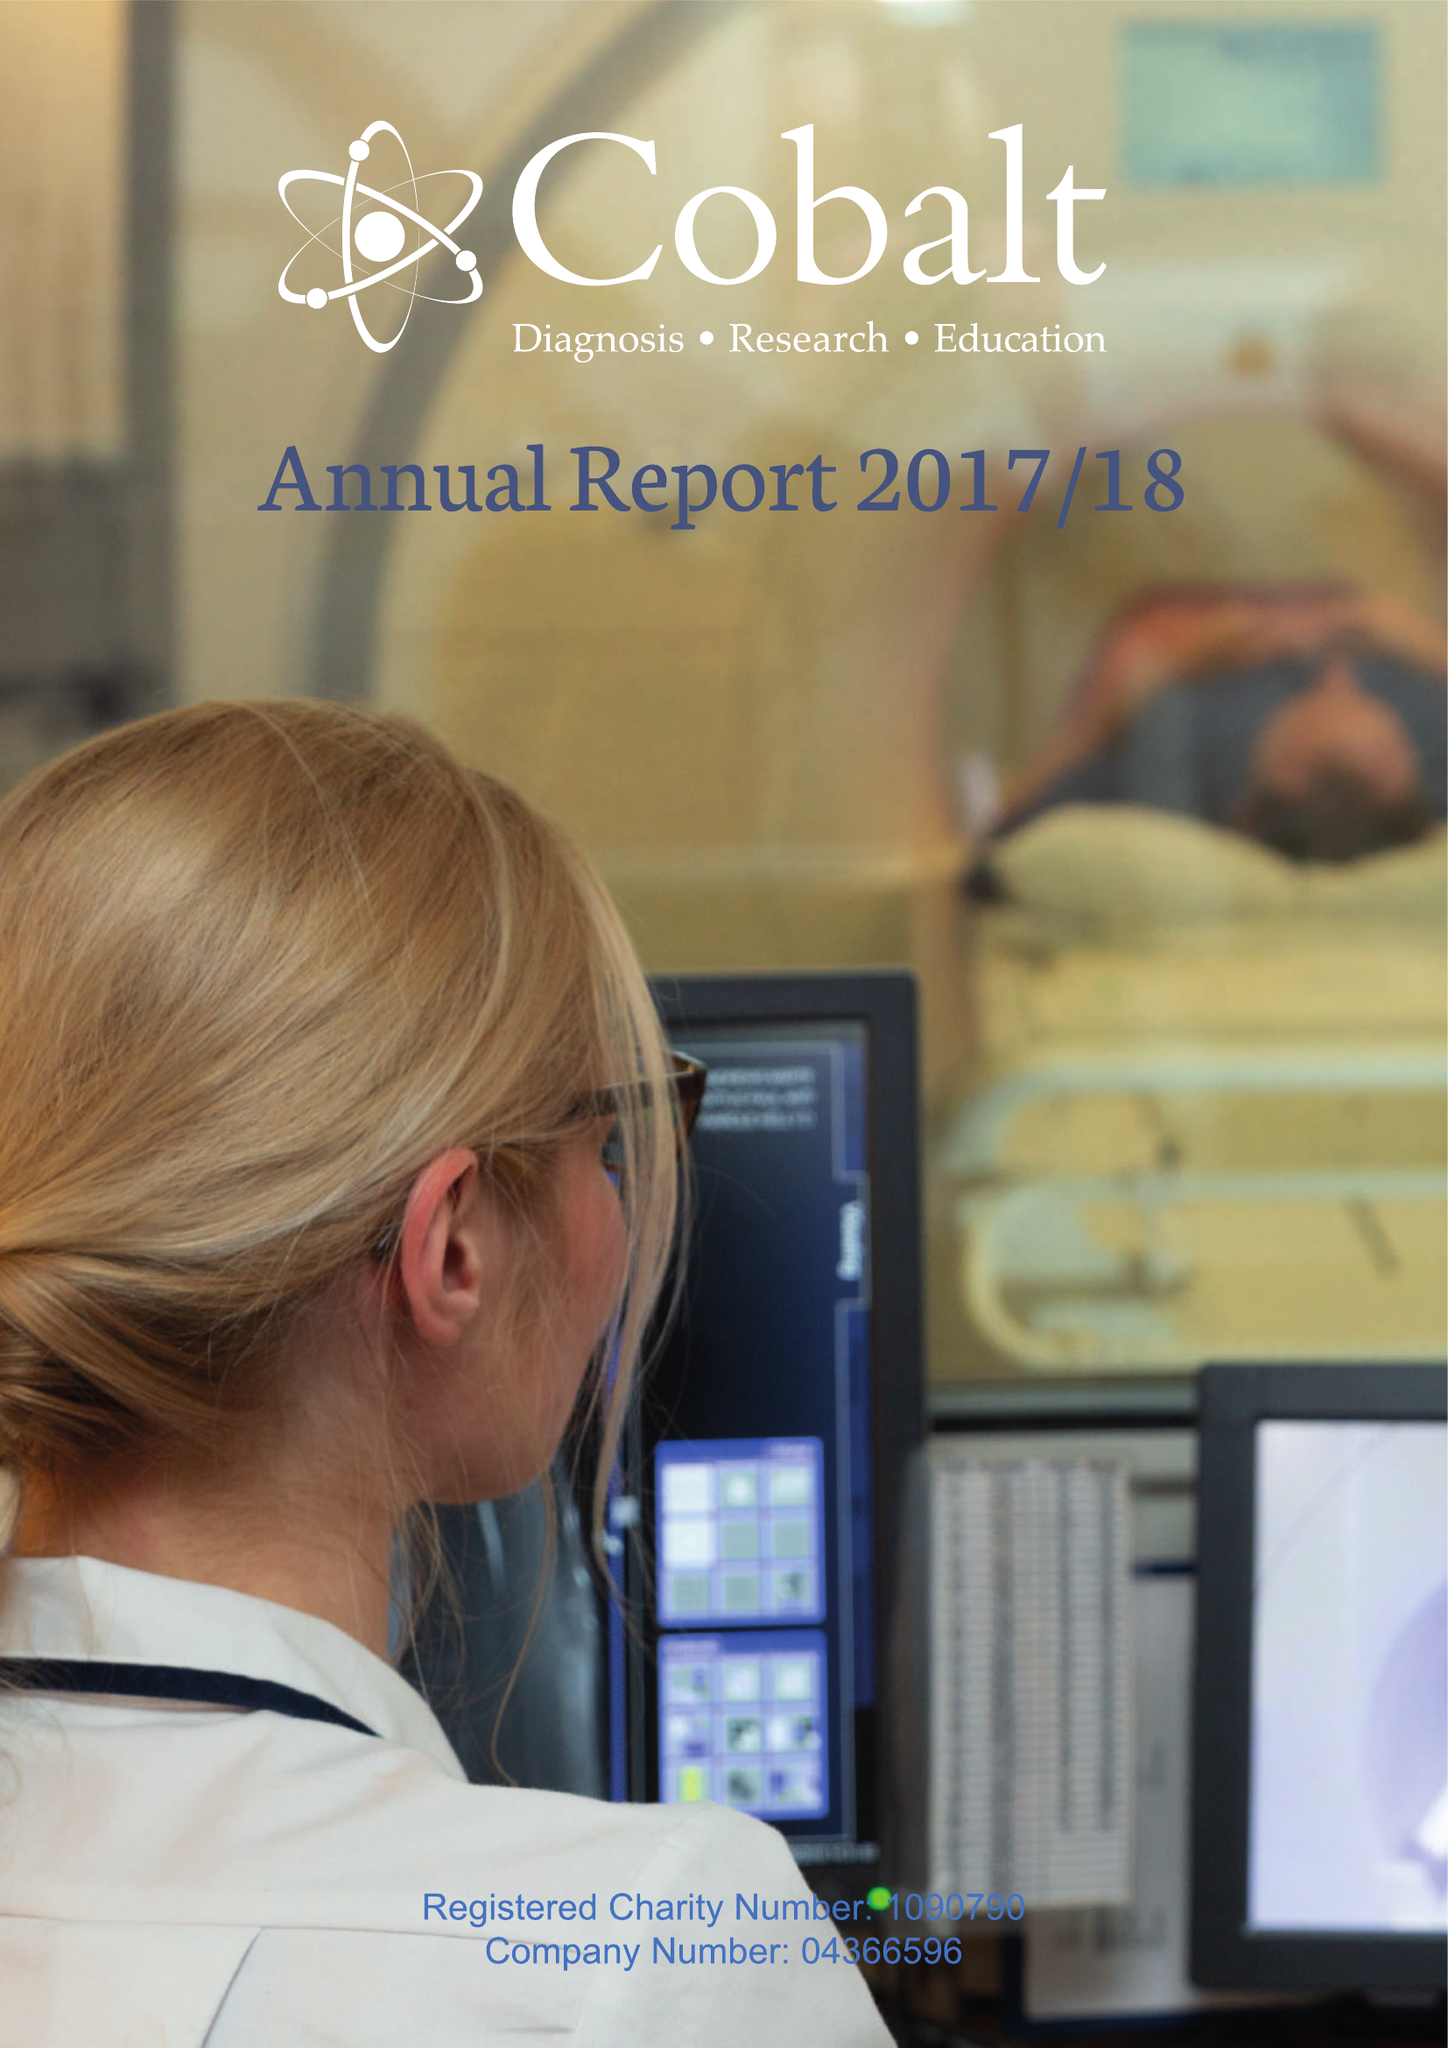What is the value for the charity_name?
Answer the question using a single word or phrase. Cobalt Health 